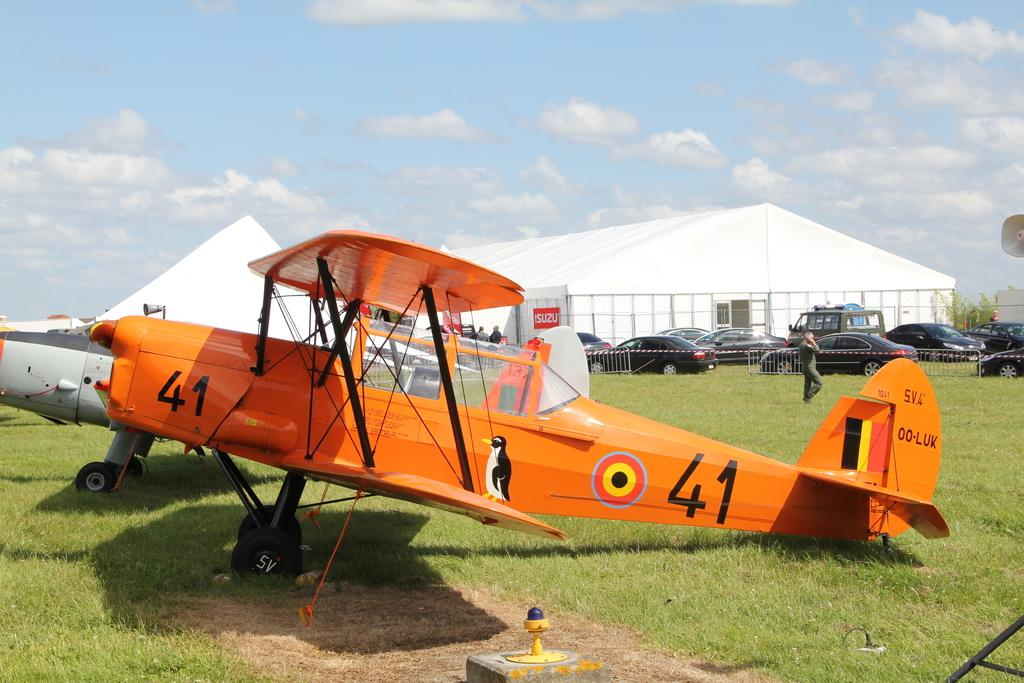<image>
Write a terse but informative summary of the picture. Old single prop plane painted in orange has a number 41 on it. 